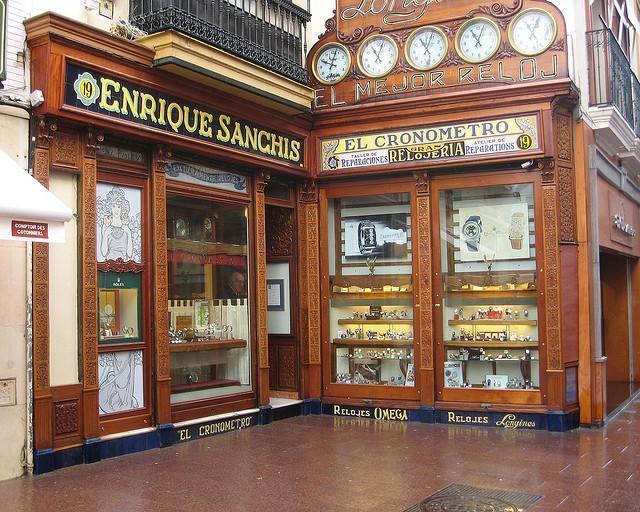How many clocks are there?
Give a very brief answer. 5. 